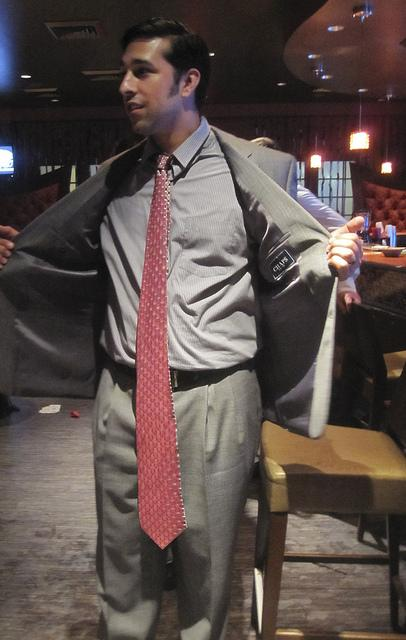What is the problem with this tie? Please explain your reasoning. too long. A man is wearing a tie that reaches down to his knees. ties are typically only long enough to reach above waist level. 